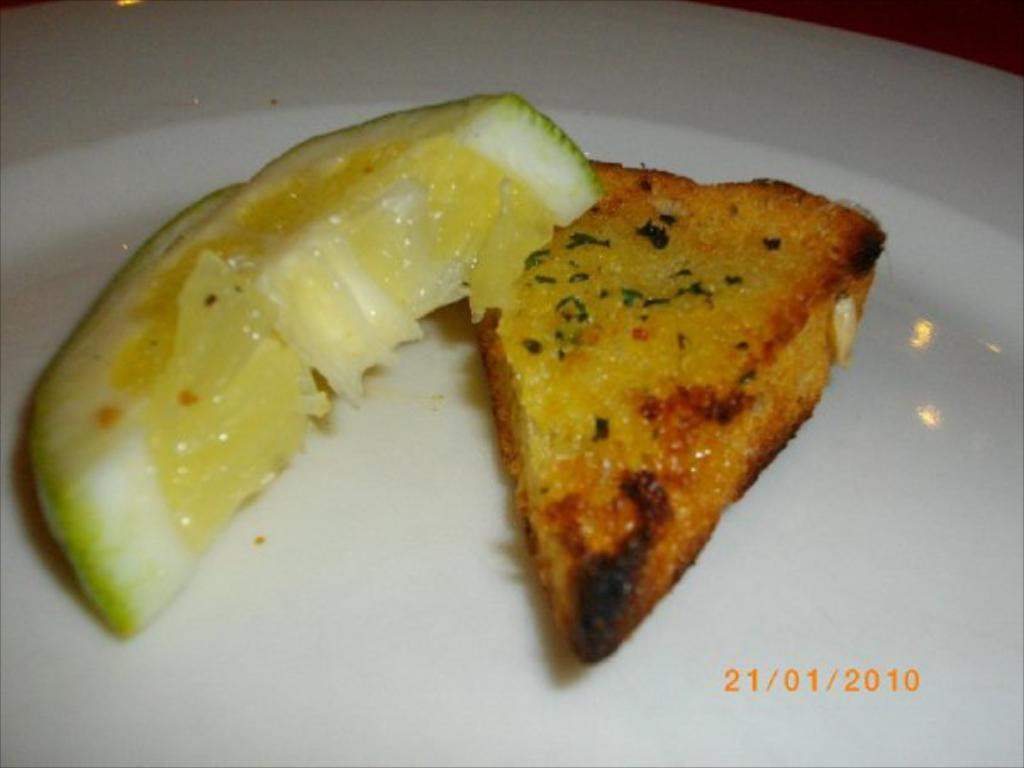What type of food is present on the left side of the image? There is a lemon piece on the left side of the image. What type of food is present on the right side of the image? There is a bread piece on the right side of the image. What color is the plate that the bread piece is on? The bread piece is on a white color plate. What type of wool is visible in the image? There is no wool present in the image. 